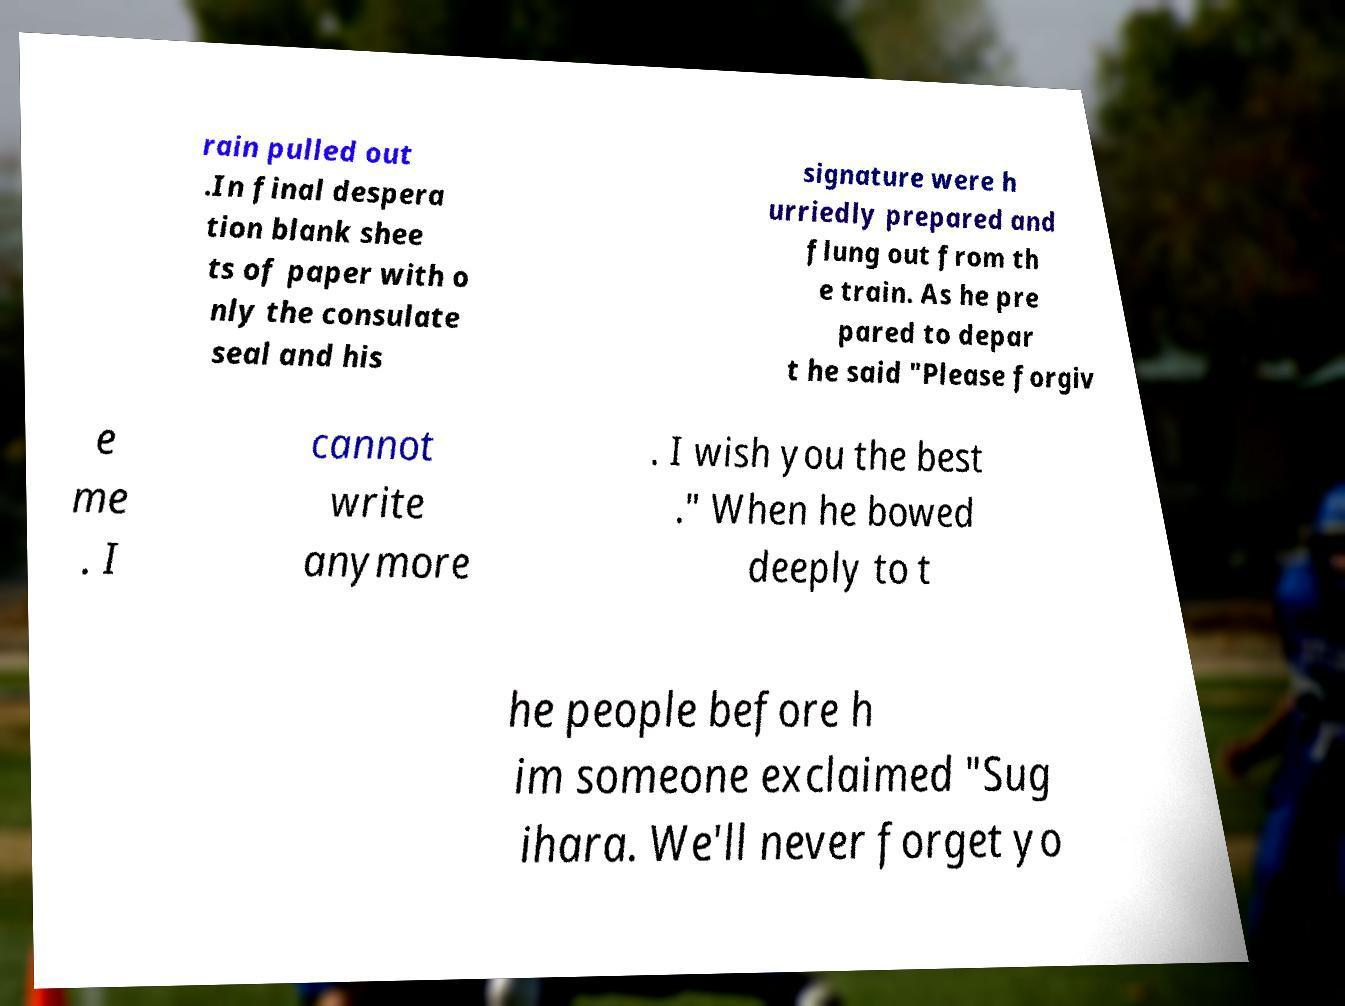Please identify and transcribe the text found in this image. rain pulled out .In final despera tion blank shee ts of paper with o nly the consulate seal and his signature were h urriedly prepared and flung out from th e train. As he pre pared to depar t he said "Please forgiv e me . I cannot write anymore . I wish you the best ." When he bowed deeply to t he people before h im someone exclaimed "Sug ihara. We'll never forget yo 